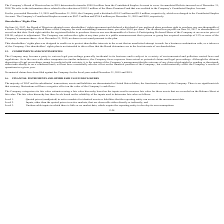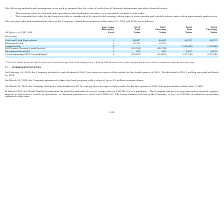From Nordic American Tankers Limited's financial document, What are the respective 2018 and 2019 fair value of the company's cash and cash equivalents? The document shows two values: 49,327 and 48,847. From the document: "Cash and Cash Equivalents 1 48,847 48,847 49,327 49,327 Cash and Cash Equivalents 1 48,847 48,847 49,327 49,327..." Also, What are the respective 2018 and 2019 fair value of the company's investment securities? The document shows two values: 4,197 and 825. From the document: "Investment Securities 1 825 825 4,197 4,197 Investment Securities 1 825 825 4,197 4,197..." Also, What are the respective 2018 and 2019 fair value of the company's vessel financing 2018 newbuildings? The document shows two values: (127,140) and (119,867). From the document: "financing 2018 Newbuildings* 2 (119,867) (119,867) (127,140) (127,140) Vessel financing 2018 Newbuildings* 2 (119,867) (119,867) (127,140) (127,140)..." Also, can you calculate: What is the average value of the 2018 and 2019 fair value of the company's cash and cash equivalents? To answer this question, I need to perform calculations using the financial data. The calculation is: (49,327 + 48,847)/2 , which equals 49087. This is based on the information: "Cash and Cash Equivalents 1 48,847 48,847 49,327 49,327 Cash and Cash Equivalents 1 48,847 48,847 49,327 49,327..." The key data points involved are: 48,847, 49,327. Also, can you calculate: What is the average value of the 2018 and 2019 fair value of the company's investment securities? To answer this question, I need to perform calculations using the financial data. The calculation is: (4,197 + 825)/2 , which equals 2511. This is based on the information: "Investment Securities 1 825 825 4,197 4,197 Investment Securities 1 825 825 4,197 4,197..." The key data points involved are: 4,197, 825. Also, can you calculate: What is the average value of the 2018 and 2019 fair value of the company's vessel financing 2018 newbuildings? To answer this question, I need to perform calculations using the financial data. The calculation is: (127,140 + 119,867)/2 , which equals 123503.5. This is based on the information: "nancing 2018 Newbuildings* 2 (119,867) (119,867) (127,140) (127,140) Vessel financing 2018 Newbuildings* 2 (119,867) (119,867) (127,140) (127,140)..." The key data points involved are: 119,867, 127,140. 